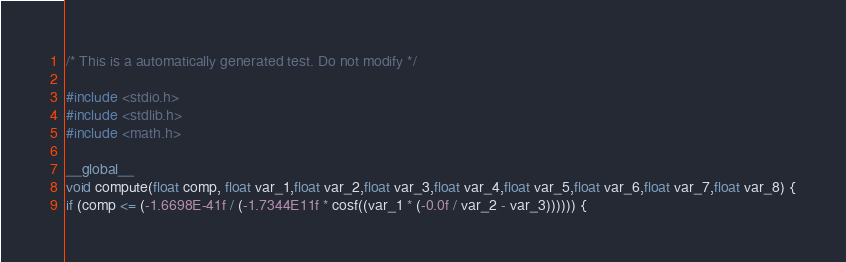<code> <loc_0><loc_0><loc_500><loc_500><_Cuda_>
/* This is a automatically generated test. Do not modify */

#include <stdio.h>
#include <stdlib.h>
#include <math.h>

__global__
void compute(float comp, float var_1,float var_2,float var_3,float var_4,float var_5,float var_6,float var_7,float var_8) {
if (comp <= (-1.6698E-41f / (-1.7344E11f * cosf((var_1 * (-0.0f / var_2 - var_3)))))) {</code> 